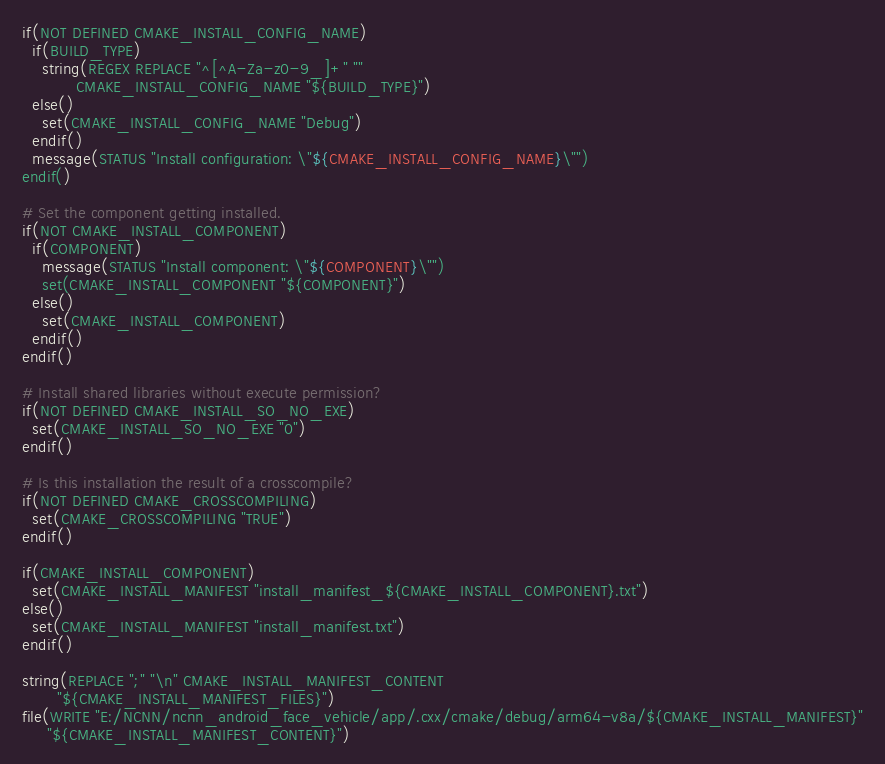Convert code to text. <code><loc_0><loc_0><loc_500><loc_500><_CMake_>if(NOT DEFINED CMAKE_INSTALL_CONFIG_NAME)
  if(BUILD_TYPE)
    string(REGEX REPLACE "^[^A-Za-z0-9_]+" ""
           CMAKE_INSTALL_CONFIG_NAME "${BUILD_TYPE}")
  else()
    set(CMAKE_INSTALL_CONFIG_NAME "Debug")
  endif()
  message(STATUS "Install configuration: \"${CMAKE_INSTALL_CONFIG_NAME}\"")
endif()

# Set the component getting installed.
if(NOT CMAKE_INSTALL_COMPONENT)
  if(COMPONENT)
    message(STATUS "Install component: \"${COMPONENT}\"")
    set(CMAKE_INSTALL_COMPONENT "${COMPONENT}")
  else()
    set(CMAKE_INSTALL_COMPONENT)
  endif()
endif()

# Install shared libraries without execute permission?
if(NOT DEFINED CMAKE_INSTALL_SO_NO_EXE)
  set(CMAKE_INSTALL_SO_NO_EXE "0")
endif()

# Is this installation the result of a crosscompile?
if(NOT DEFINED CMAKE_CROSSCOMPILING)
  set(CMAKE_CROSSCOMPILING "TRUE")
endif()

if(CMAKE_INSTALL_COMPONENT)
  set(CMAKE_INSTALL_MANIFEST "install_manifest_${CMAKE_INSTALL_COMPONENT}.txt")
else()
  set(CMAKE_INSTALL_MANIFEST "install_manifest.txt")
endif()

string(REPLACE ";" "\n" CMAKE_INSTALL_MANIFEST_CONTENT
       "${CMAKE_INSTALL_MANIFEST_FILES}")
file(WRITE "E:/NCNN/ncnn_android_face_vehicle/app/.cxx/cmake/debug/arm64-v8a/${CMAKE_INSTALL_MANIFEST}"
     "${CMAKE_INSTALL_MANIFEST_CONTENT}")
</code> 